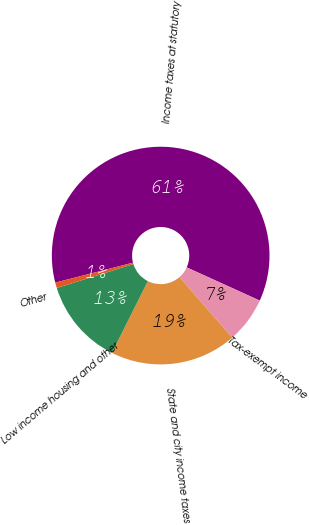Convert chart. <chart><loc_0><loc_0><loc_500><loc_500><pie_chart><fcel>Income taxes at statutory<fcel>Tax-exempt income<fcel>State and city income taxes<fcel>Low income housing and other<fcel>Other<nl><fcel>60.79%<fcel>6.8%<fcel>18.8%<fcel>12.8%<fcel>0.81%<nl></chart> 